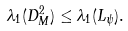<formula> <loc_0><loc_0><loc_500><loc_500>\lambda _ { 1 } ( D _ { M } ^ { 2 } ) \leq \lambda _ { 1 } ( L _ { \psi } ) .</formula> 